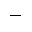<formula> <loc_0><loc_0><loc_500><loc_500>-</formula> 